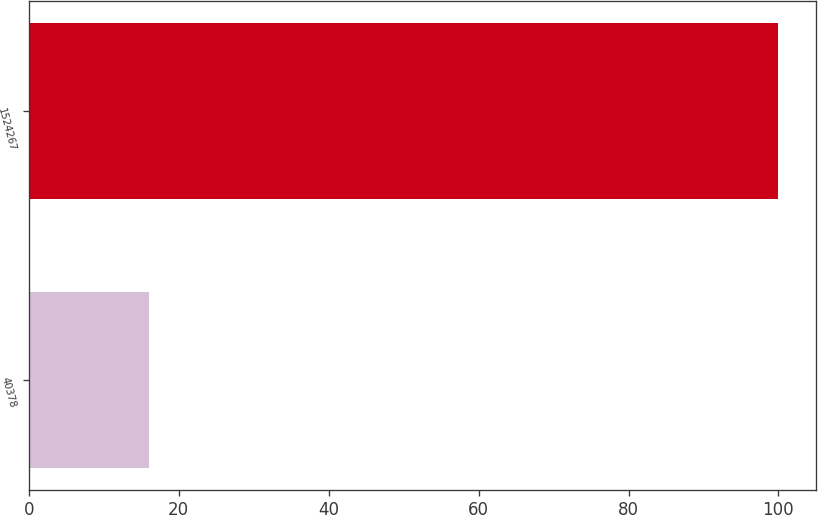Convert chart to OTSL. <chart><loc_0><loc_0><loc_500><loc_500><bar_chart><fcel>40378<fcel>1524267<nl><fcel>16<fcel>100<nl></chart> 